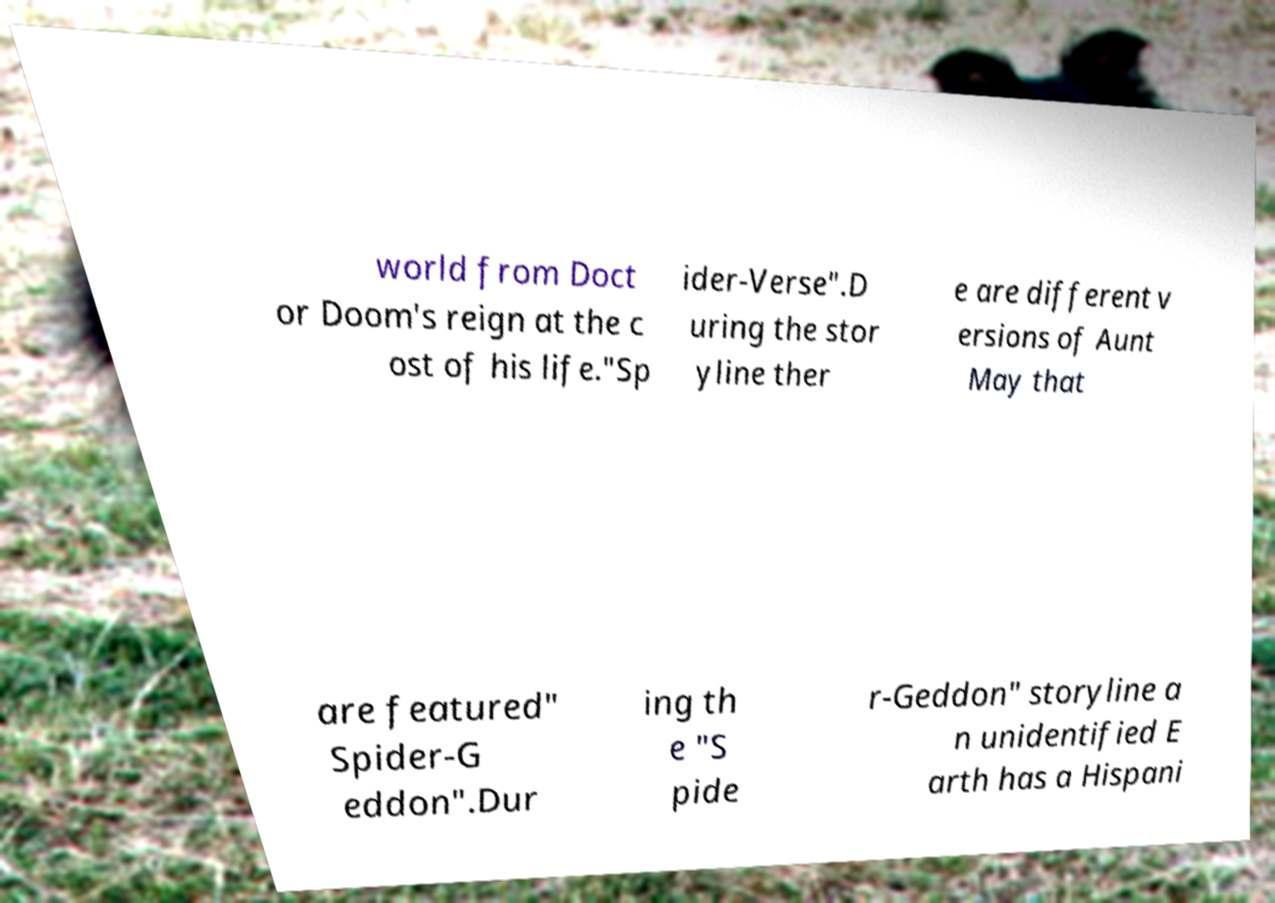For documentation purposes, I need the text within this image transcribed. Could you provide that? world from Doct or Doom's reign at the c ost of his life."Sp ider-Verse".D uring the stor yline ther e are different v ersions of Aunt May that are featured" Spider-G eddon".Dur ing th e "S pide r-Geddon" storyline a n unidentified E arth has a Hispani 